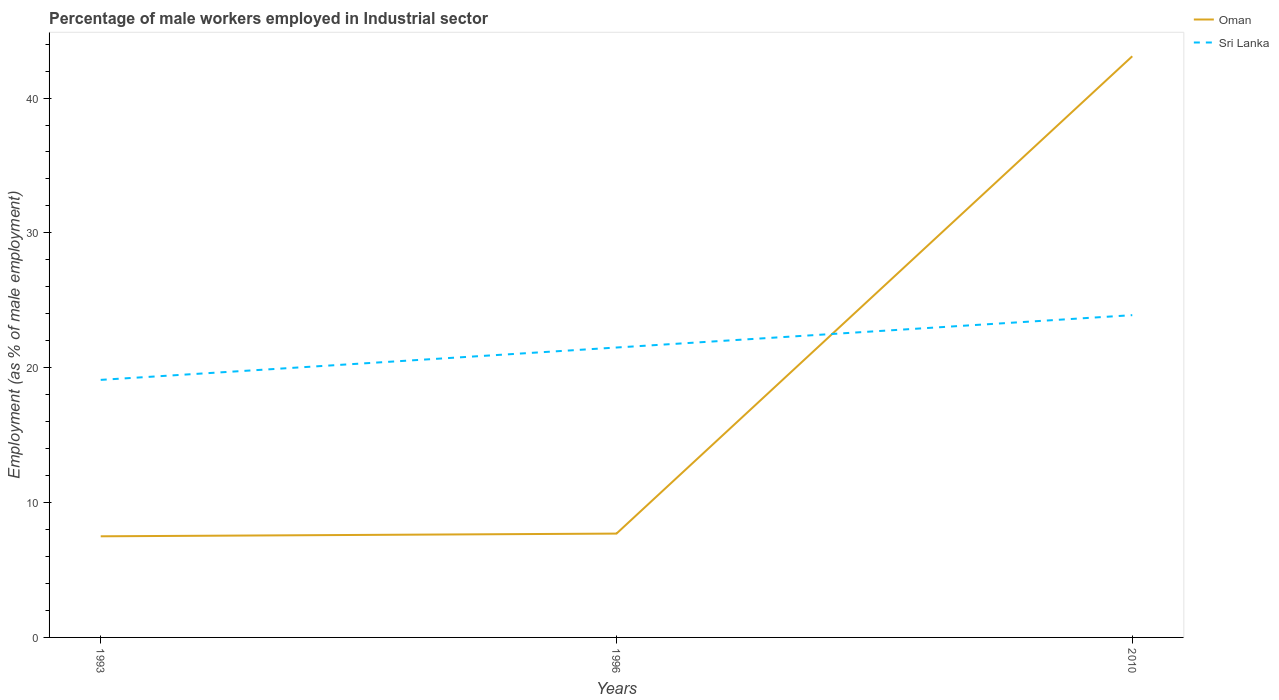Does the line corresponding to Oman intersect with the line corresponding to Sri Lanka?
Ensure brevity in your answer.  Yes. In which year was the percentage of male workers employed in Industrial sector in Sri Lanka maximum?
Keep it short and to the point. 1993. What is the total percentage of male workers employed in Industrial sector in Sri Lanka in the graph?
Offer a very short reply. -2.4. What is the difference between the highest and the second highest percentage of male workers employed in Industrial sector in Sri Lanka?
Ensure brevity in your answer.  4.8. How many years are there in the graph?
Your response must be concise. 3. Are the values on the major ticks of Y-axis written in scientific E-notation?
Offer a terse response. No. Does the graph contain grids?
Ensure brevity in your answer.  No. Where does the legend appear in the graph?
Your answer should be compact. Top right. How many legend labels are there?
Your answer should be very brief. 2. What is the title of the graph?
Keep it short and to the point. Percentage of male workers employed in Industrial sector. What is the label or title of the Y-axis?
Your answer should be very brief. Employment (as % of male employment). What is the Employment (as % of male employment) in Oman in 1993?
Your response must be concise. 7.5. What is the Employment (as % of male employment) of Sri Lanka in 1993?
Ensure brevity in your answer.  19.1. What is the Employment (as % of male employment) of Oman in 1996?
Offer a terse response. 7.7. What is the Employment (as % of male employment) of Oman in 2010?
Your answer should be compact. 43.1. What is the Employment (as % of male employment) of Sri Lanka in 2010?
Your answer should be very brief. 23.9. Across all years, what is the maximum Employment (as % of male employment) of Oman?
Give a very brief answer. 43.1. Across all years, what is the maximum Employment (as % of male employment) of Sri Lanka?
Provide a succinct answer. 23.9. Across all years, what is the minimum Employment (as % of male employment) of Oman?
Your answer should be very brief. 7.5. Across all years, what is the minimum Employment (as % of male employment) in Sri Lanka?
Offer a very short reply. 19.1. What is the total Employment (as % of male employment) of Oman in the graph?
Ensure brevity in your answer.  58.3. What is the total Employment (as % of male employment) in Sri Lanka in the graph?
Your answer should be very brief. 64.5. What is the difference between the Employment (as % of male employment) of Sri Lanka in 1993 and that in 1996?
Offer a terse response. -2.4. What is the difference between the Employment (as % of male employment) in Oman in 1993 and that in 2010?
Your answer should be very brief. -35.6. What is the difference between the Employment (as % of male employment) of Sri Lanka in 1993 and that in 2010?
Provide a short and direct response. -4.8. What is the difference between the Employment (as % of male employment) in Oman in 1996 and that in 2010?
Ensure brevity in your answer.  -35.4. What is the difference between the Employment (as % of male employment) of Sri Lanka in 1996 and that in 2010?
Ensure brevity in your answer.  -2.4. What is the difference between the Employment (as % of male employment) in Oman in 1993 and the Employment (as % of male employment) in Sri Lanka in 2010?
Give a very brief answer. -16.4. What is the difference between the Employment (as % of male employment) of Oman in 1996 and the Employment (as % of male employment) of Sri Lanka in 2010?
Keep it short and to the point. -16.2. What is the average Employment (as % of male employment) of Oman per year?
Provide a succinct answer. 19.43. What is the average Employment (as % of male employment) in Sri Lanka per year?
Keep it short and to the point. 21.5. In the year 1996, what is the difference between the Employment (as % of male employment) of Oman and Employment (as % of male employment) of Sri Lanka?
Make the answer very short. -13.8. In the year 2010, what is the difference between the Employment (as % of male employment) in Oman and Employment (as % of male employment) in Sri Lanka?
Make the answer very short. 19.2. What is the ratio of the Employment (as % of male employment) of Oman in 1993 to that in 1996?
Give a very brief answer. 0.97. What is the ratio of the Employment (as % of male employment) of Sri Lanka in 1993 to that in 1996?
Your answer should be compact. 0.89. What is the ratio of the Employment (as % of male employment) in Oman in 1993 to that in 2010?
Your response must be concise. 0.17. What is the ratio of the Employment (as % of male employment) of Sri Lanka in 1993 to that in 2010?
Make the answer very short. 0.8. What is the ratio of the Employment (as % of male employment) of Oman in 1996 to that in 2010?
Keep it short and to the point. 0.18. What is the ratio of the Employment (as % of male employment) in Sri Lanka in 1996 to that in 2010?
Provide a succinct answer. 0.9. What is the difference between the highest and the second highest Employment (as % of male employment) of Oman?
Give a very brief answer. 35.4. What is the difference between the highest and the second highest Employment (as % of male employment) in Sri Lanka?
Your response must be concise. 2.4. What is the difference between the highest and the lowest Employment (as % of male employment) in Oman?
Make the answer very short. 35.6. 